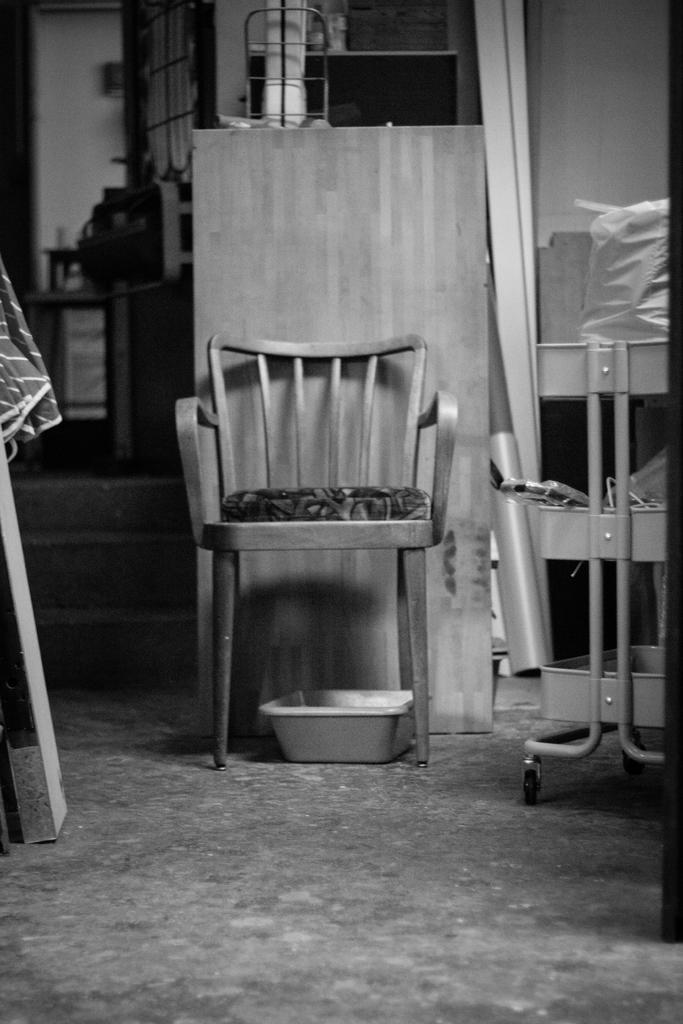In one or two sentences, can you explain what this image depicts? This is a black and white image where we can see a chair, a pan and a few more objects in the background. 